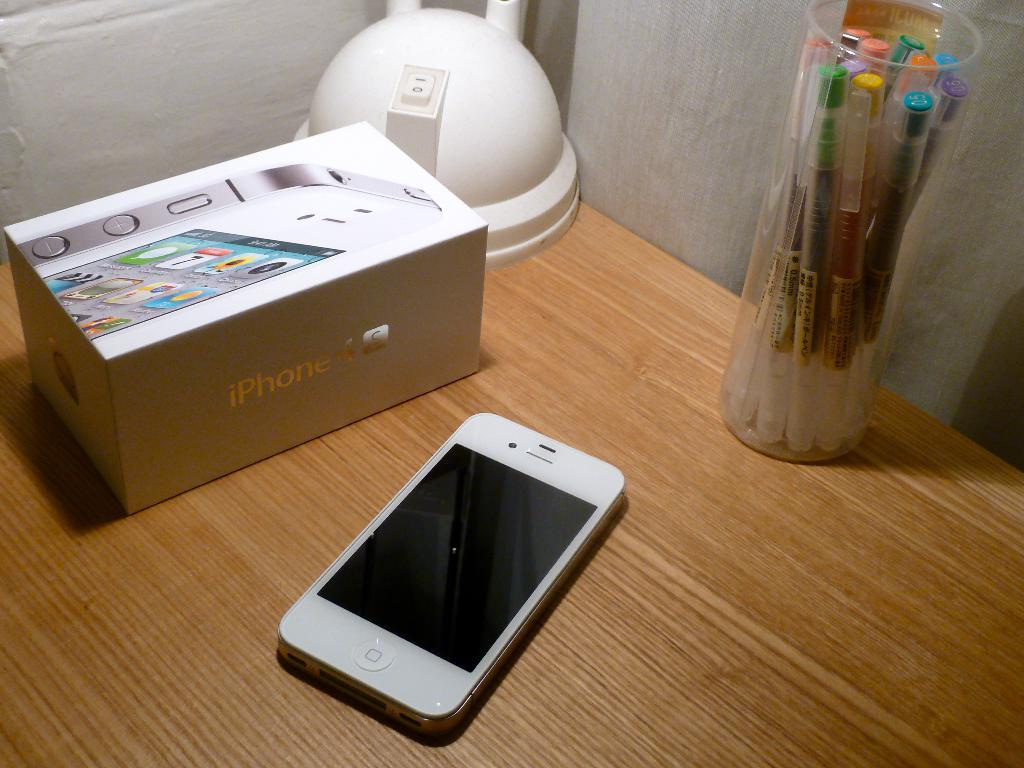<image>
Present a compact description of the photo's key features. a box with the word iPhone on it 